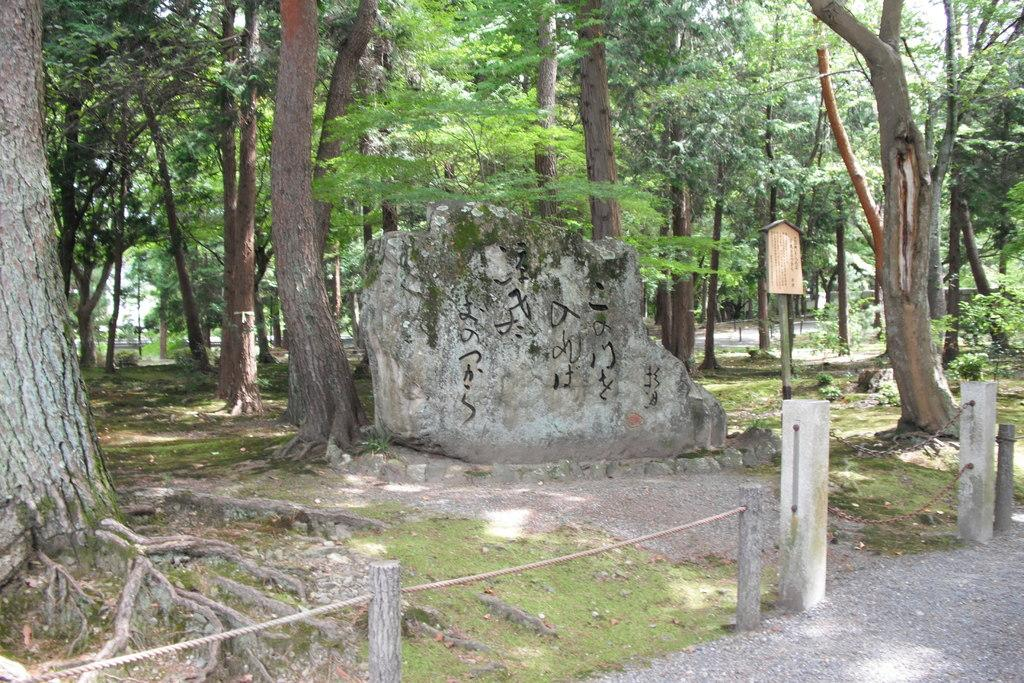What objects are connected by a rope in the image? There are wooden poles with a rope in the image. What is visible behind the wooden poles? There is a wall visible behind the poles. What can be seen in the distance in the image? Trees are present in the background of the image. How many women are expressing regret in the image? There are no women present in the image, nor is there any indication of regret. 